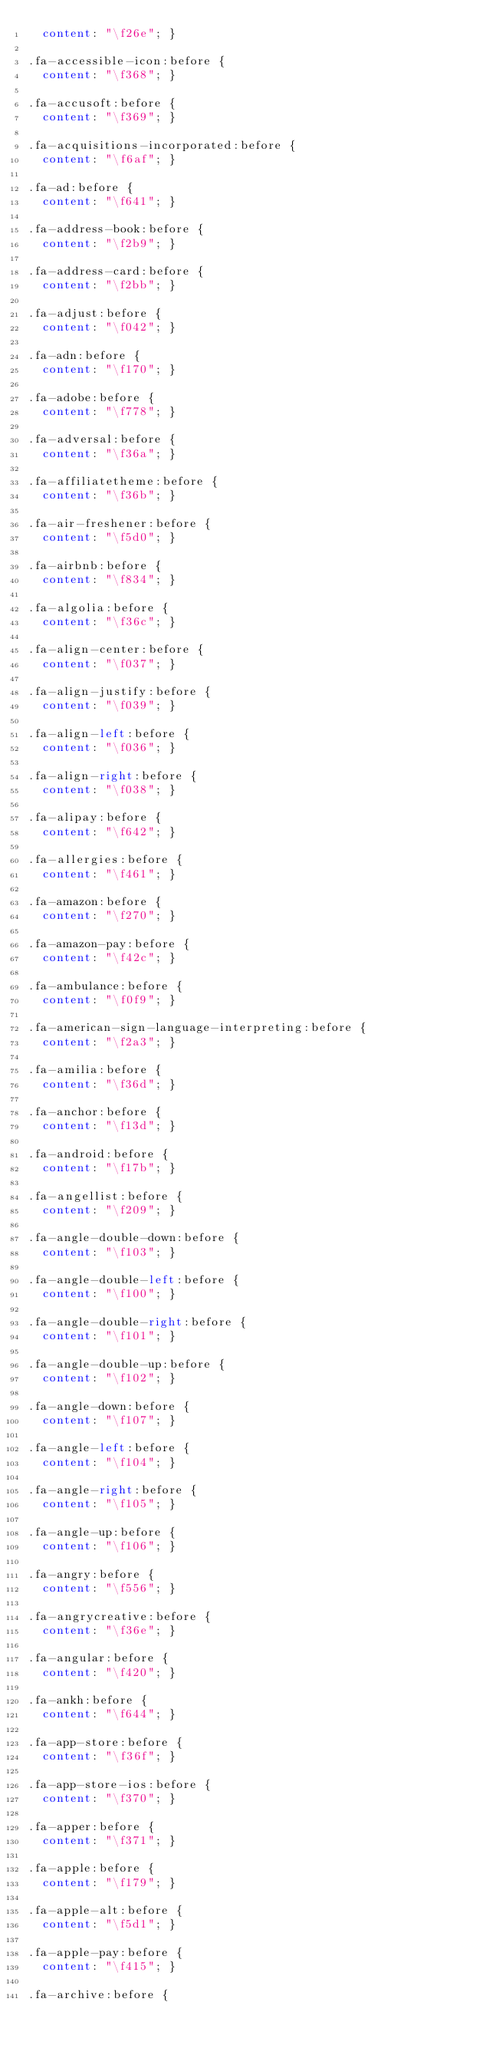Convert code to text. <code><loc_0><loc_0><loc_500><loc_500><_CSS_>  content: "\f26e"; }

.fa-accessible-icon:before {
  content: "\f368"; }

.fa-accusoft:before {
  content: "\f369"; }

.fa-acquisitions-incorporated:before {
  content: "\f6af"; }

.fa-ad:before {
  content: "\f641"; }

.fa-address-book:before {
  content: "\f2b9"; }

.fa-address-card:before {
  content: "\f2bb"; }

.fa-adjust:before {
  content: "\f042"; }

.fa-adn:before {
  content: "\f170"; }

.fa-adobe:before {
  content: "\f778"; }

.fa-adversal:before {
  content: "\f36a"; }

.fa-affiliatetheme:before {
  content: "\f36b"; }

.fa-air-freshener:before {
  content: "\f5d0"; }

.fa-airbnb:before {
  content: "\f834"; }

.fa-algolia:before {
  content: "\f36c"; }

.fa-align-center:before {
  content: "\f037"; }

.fa-align-justify:before {
  content: "\f039"; }

.fa-align-left:before {
  content: "\f036"; }

.fa-align-right:before {
  content: "\f038"; }

.fa-alipay:before {
  content: "\f642"; }

.fa-allergies:before {
  content: "\f461"; }

.fa-amazon:before {
  content: "\f270"; }

.fa-amazon-pay:before {
  content: "\f42c"; }

.fa-ambulance:before {
  content: "\f0f9"; }

.fa-american-sign-language-interpreting:before {
  content: "\f2a3"; }

.fa-amilia:before {
  content: "\f36d"; }

.fa-anchor:before {
  content: "\f13d"; }

.fa-android:before {
  content: "\f17b"; }

.fa-angellist:before {
  content: "\f209"; }

.fa-angle-double-down:before {
  content: "\f103"; }

.fa-angle-double-left:before {
  content: "\f100"; }

.fa-angle-double-right:before {
  content: "\f101"; }

.fa-angle-double-up:before {
  content: "\f102"; }

.fa-angle-down:before {
  content: "\f107"; }

.fa-angle-left:before {
  content: "\f104"; }

.fa-angle-right:before {
  content: "\f105"; }

.fa-angle-up:before {
  content: "\f106"; }

.fa-angry:before {
  content: "\f556"; }

.fa-angrycreative:before {
  content: "\f36e"; }

.fa-angular:before {
  content: "\f420"; }

.fa-ankh:before {
  content: "\f644"; }

.fa-app-store:before {
  content: "\f36f"; }

.fa-app-store-ios:before {
  content: "\f370"; }

.fa-apper:before {
  content: "\f371"; }

.fa-apple:before {
  content: "\f179"; }

.fa-apple-alt:before {
  content: "\f5d1"; }

.fa-apple-pay:before {
  content: "\f415"; }

.fa-archive:before {</code> 